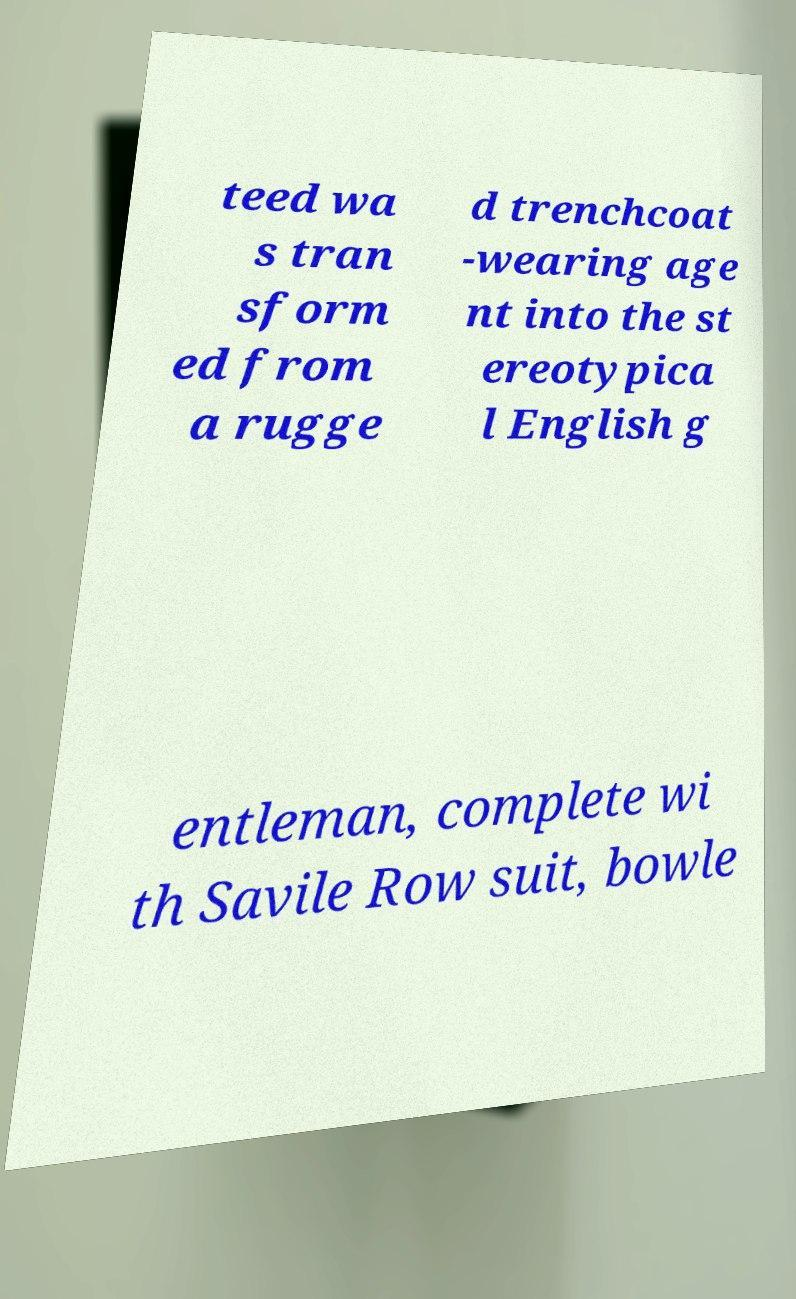Can you read and provide the text displayed in the image?This photo seems to have some interesting text. Can you extract and type it out for me? teed wa s tran sform ed from a rugge d trenchcoat -wearing age nt into the st ereotypica l English g entleman, complete wi th Savile Row suit, bowle 